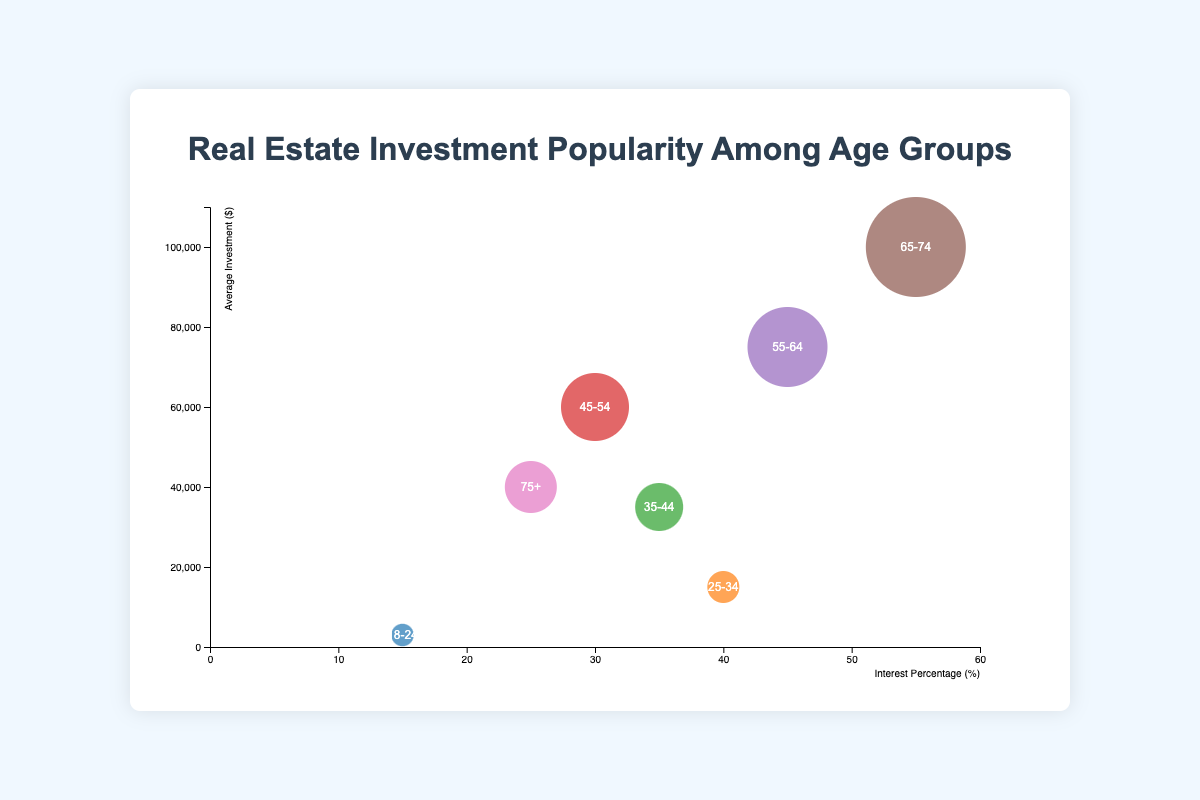What is the age group with the lowest interest percentage in real estate investment? From the chart, the age group "18-24" shows the smallest bubble on the X-axis, which represents the interest percentage.
Answer: 18-24 Which age group has the highest average investment amount? Looking at the Y-axis and the bubble size, the largest bubble on the Y-axis is "65-74", indicating this group has the highest average investment amount.
Answer: 65-74 What is the average investment amount for the "35-44" age group? The chart displays the average investment amount directly for each age group. For "35-44", it is shown as $35,000.
Answer: $35,000 Compare the interest percentages of the "25-34" and "45-54" age groups. Which is higher? By examining the X-axis values for both age groups, "25-34" has a higher interest percentage at 40%, compared to "45-54" at 30%.
Answer: 25-34 What is the total interest percentage of the "55-64" and "75+" age groups combined? Adding the interest percentages of these two groups, "55-64" at 45% and "75+" at 25%, the total is 45% + 25% = 70%.
Answer: 70% Which age group has a moderate interest percentage around 35%? From the chart, the "35-44" age group has an interest percentage of 35%, which matches the given criterion.
Answer: 35-44 Is the age group "55-64" more interested in real estate investment than "45-54"? The chart shows the interest percentages on the X-axis. "55-64" has 45%, which is higher than "45-54" at 30%.
Answer: Yes For which age group does the chart show an average investment around $40,000? The "75+" age group displays an average investment of $40,000, according to the Y-axis.
Answer: 75+ What trend can you observe between age groups and their average investment in real estate? There is a general trend showing that as the age of the groups increases, their average investment amounts also increase, indicated by the higher positions on the Y-axis and larger bubble sizes.
Answer: Increasing trend with age How do the average investments of "25-34" and "35-44" age groups compare? Looking at the Y-axis values, "25-34" has an average investment of $15,000, while "35-44" has $35,000. Thus, "35-44" has a higher average investment.
Answer: 35-44 